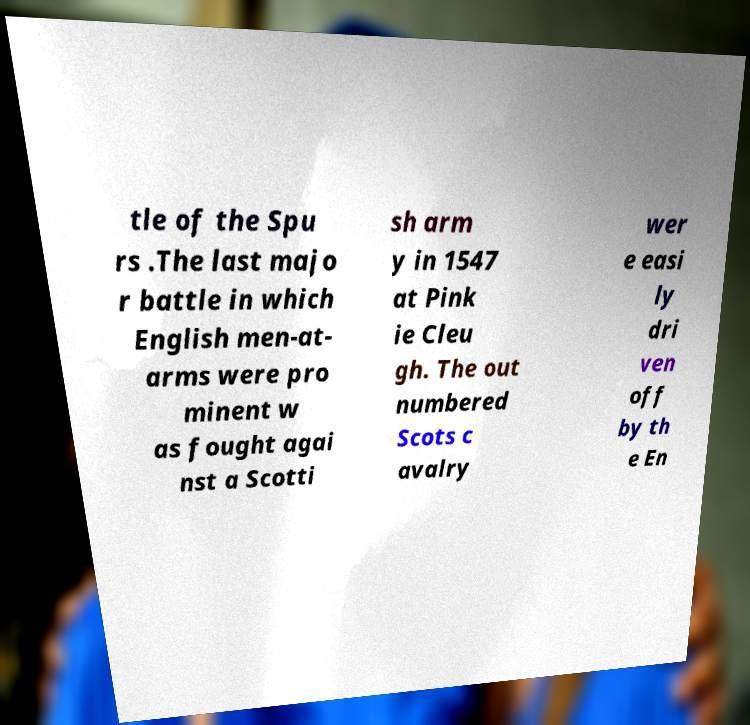Can you read and provide the text displayed in the image?This photo seems to have some interesting text. Can you extract and type it out for me? tle of the Spu rs .The last majo r battle in which English men-at- arms were pro minent w as fought agai nst a Scotti sh arm y in 1547 at Pink ie Cleu gh. The out numbered Scots c avalry wer e easi ly dri ven off by th e En 